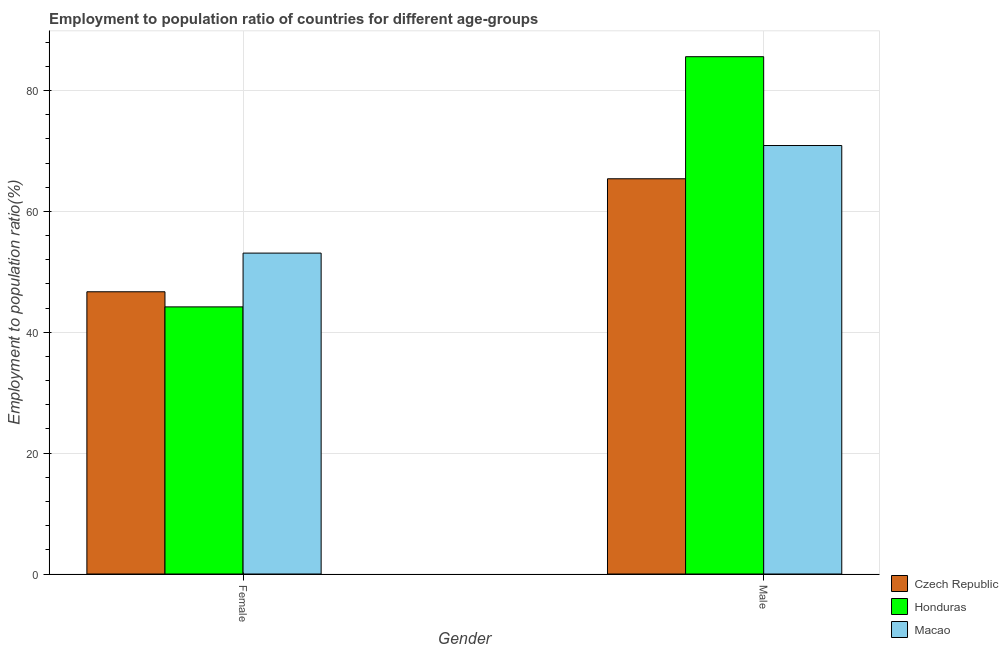How many different coloured bars are there?
Ensure brevity in your answer.  3. What is the label of the 1st group of bars from the left?
Your answer should be very brief. Female. What is the employment to population ratio(female) in Honduras?
Offer a very short reply. 44.2. Across all countries, what is the maximum employment to population ratio(male)?
Provide a short and direct response. 85.6. Across all countries, what is the minimum employment to population ratio(female)?
Your response must be concise. 44.2. In which country was the employment to population ratio(female) maximum?
Give a very brief answer. Macao. In which country was the employment to population ratio(female) minimum?
Offer a terse response. Honduras. What is the total employment to population ratio(male) in the graph?
Your answer should be very brief. 221.9. What is the difference between the employment to population ratio(male) in Macao and that in Honduras?
Make the answer very short. -14.7. What is the difference between the employment to population ratio(female) in Macao and the employment to population ratio(male) in Czech Republic?
Offer a terse response. -12.3. What is the average employment to population ratio(female) per country?
Offer a terse response. 48. What is the difference between the employment to population ratio(male) and employment to population ratio(female) in Czech Republic?
Give a very brief answer. 18.7. In how many countries, is the employment to population ratio(male) greater than 40 %?
Offer a terse response. 3. What is the ratio of the employment to population ratio(female) in Honduras to that in Macao?
Keep it short and to the point. 0.83. Is the employment to population ratio(female) in Czech Republic less than that in Macao?
Make the answer very short. Yes. In how many countries, is the employment to population ratio(male) greater than the average employment to population ratio(male) taken over all countries?
Your answer should be compact. 1. What does the 3rd bar from the left in Female represents?
Give a very brief answer. Macao. What does the 1st bar from the right in Male represents?
Your answer should be very brief. Macao. How many bars are there?
Your answer should be compact. 6. Are all the bars in the graph horizontal?
Your response must be concise. No. How many countries are there in the graph?
Provide a short and direct response. 3. Are the values on the major ticks of Y-axis written in scientific E-notation?
Offer a very short reply. No. Does the graph contain any zero values?
Make the answer very short. No. Does the graph contain grids?
Your response must be concise. Yes. How many legend labels are there?
Your answer should be compact. 3. How are the legend labels stacked?
Your response must be concise. Vertical. What is the title of the graph?
Provide a succinct answer. Employment to population ratio of countries for different age-groups. Does "Middle East & North Africa (developing only)" appear as one of the legend labels in the graph?
Provide a succinct answer. No. What is the Employment to population ratio(%) in Czech Republic in Female?
Your response must be concise. 46.7. What is the Employment to population ratio(%) in Honduras in Female?
Your response must be concise. 44.2. What is the Employment to population ratio(%) of Macao in Female?
Offer a terse response. 53.1. What is the Employment to population ratio(%) in Czech Republic in Male?
Offer a terse response. 65.4. What is the Employment to population ratio(%) in Honduras in Male?
Offer a very short reply. 85.6. What is the Employment to population ratio(%) in Macao in Male?
Keep it short and to the point. 70.9. Across all Gender, what is the maximum Employment to population ratio(%) in Czech Republic?
Provide a short and direct response. 65.4. Across all Gender, what is the maximum Employment to population ratio(%) in Honduras?
Offer a very short reply. 85.6. Across all Gender, what is the maximum Employment to population ratio(%) in Macao?
Offer a terse response. 70.9. Across all Gender, what is the minimum Employment to population ratio(%) of Czech Republic?
Keep it short and to the point. 46.7. Across all Gender, what is the minimum Employment to population ratio(%) in Honduras?
Your response must be concise. 44.2. Across all Gender, what is the minimum Employment to population ratio(%) in Macao?
Provide a short and direct response. 53.1. What is the total Employment to population ratio(%) of Czech Republic in the graph?
Keep it short and to the point. 112.1. What is the total Employment to population ratio(%) of Honduras in the graph?
Provide a succinct answer. 129.8. What is the total Employment to population ratio(%) in Macao in the graph?
Provide a short and direct response. 124. What is the difference between the Employment to population ratio(%) of Czech Republic in Female and that in Male?
Your answer should be compact. -18.7. What is the difference between the Employment to population ratio(%) in Honduras in Female and that in Male?
Provide a succinct answer. -41.4. What is the difference between the Employment to population ratio(%) in Macao in Female and that in Male?
Give a very brief answer. -17.8. What is the difference between the Employment to population ratio(%) in Czech Republic in Female and the Employment to population ratio(%) in Honduras in Male?
Keep it short and to the point. -38.9. What is the difference between the Employment to population ratio(%) of Czech Republic in Female and the Employment to population ratio(%) of Macao in Male?
Give a very brief answer. -24.2. What is the difference between the Employment to population ratio(%) of Honduras in Female and the Employment to population ratio(%) of Macao in Male?
Offer a very short reply. -26.7. What is the average Employment to population ratio(%) of Czech Republic per Gender?
Keep it short and to the point. 56.05. What is the average Employment to population ratio(%) in Honduras per Gender?
Your answer should be compact. 64.9. What is the difference between the Employment to population ratio(%) in Honduras and Employment to population ratio(%) in Macao in Female?
Offer a terse response. -8.9. What is the difference between the Employment to population ratio(%) of Czech Republic and Employment to population ratio(%) of Honduras in Male?
Provide a succinct answer. -20.2. What is the difference between the Employment to population ratio(%) of Czech Republic and Employment to population ratio(%) of Macao in Male?
Ensure brevity in your answer.  -5.5. What is the difference between the Employment to population ratio(%) in Honduras and Employment to population ratio(%) in Macao in Male?
Give a very brief answer. 14.7. What is the ratio of the Employment to population ratio(%) of Czech Republic in Female to that in Male?
Offer a terse response. 0.71. What is the ratio of the Employment to population ratio(%) of Honduras in Female to that in Male?
Make the answer very short. 0.52. What is the ratio of the Employment to population ratio(%) in Macao in Female to that in Male?
Your answer should be very brief. 0.75. What is the difference between the highest and the second highest Employment to population ratio(%) of Czech Republic?
Your response must be concise. 18.7. What is the difference between the highest and the second highest Employment to population ratio(%) in Honduras?
Offer a very short reply. 41.4. What is the difference between the highest and the lowest Employment to population ratio(%) in Honduras?
Make the answer very short. 41.4. What is the difference between the highest and the lowest Employment to population ratio(%) in Macao?
Your response must be concise. 17.8. 